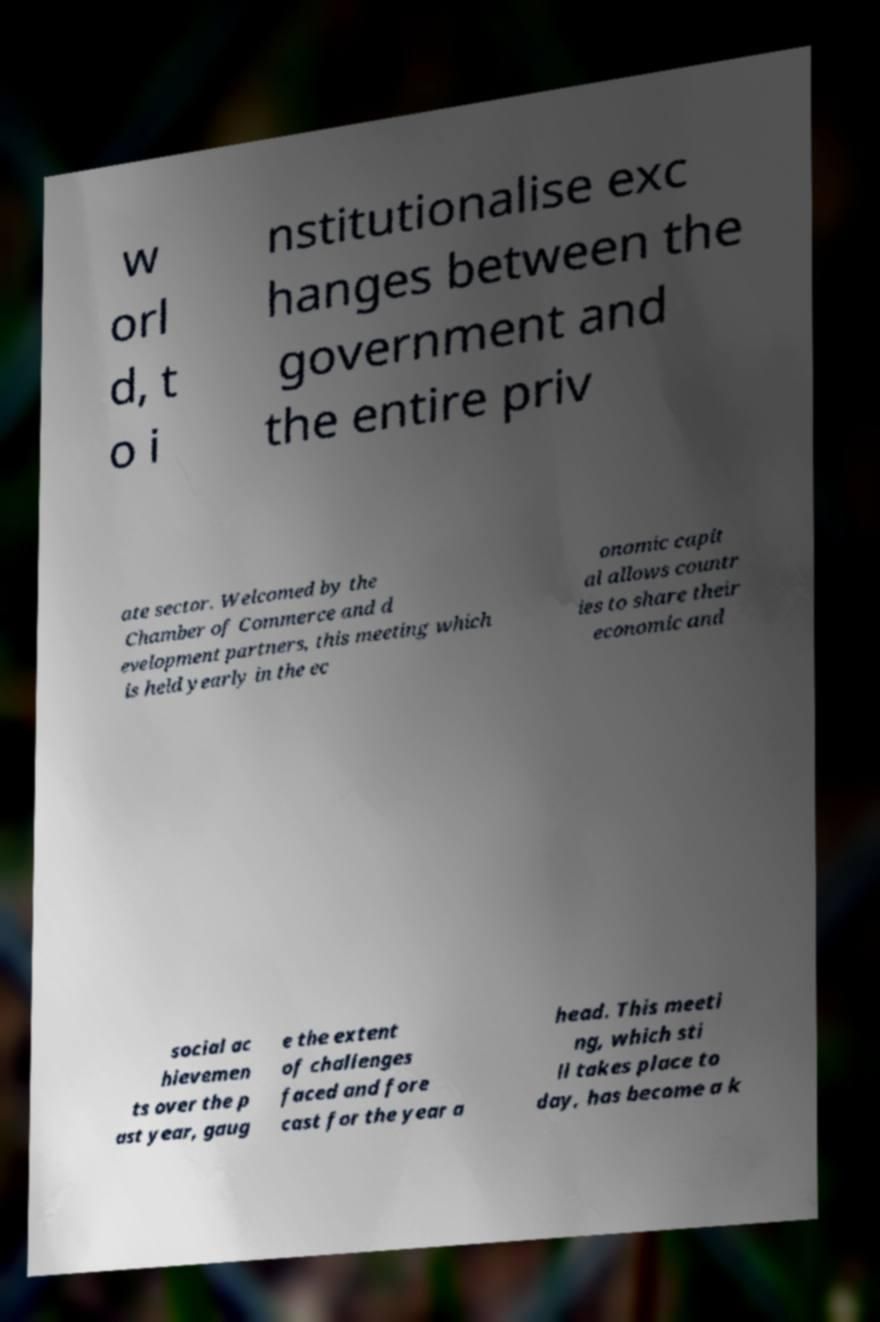There's text embedded in this image that I need extracted. Can you transcribe it verbatim? w orl d, t o i nstitutionalise exc hanges between the government and the entire priv ate sector. Welcomed by the Chamber of Commerce and d evelopment partners, this meeting which is held yearly in the ec onomic capit al allows countr ies to share their economic and social ac hievemen ts over the p ast year, gaug e the extent of challenges faced and fore cast for the year a head. This meeti ng, which sti ll takes place to day, has become a k 